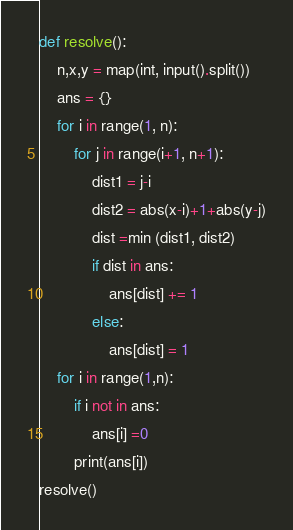Convert code to text. <code><loc_0><loc_0><loc_500><loc_500><_Python_>def resolve():
    n,x,y = map(int, input().split())
    ans = {}
    for i in range(1, n):
        for j in range(i+1, n+1):
            dist1 = j-i
            dist2 = abs(x-i)+1+abs(y-j)
            dist =min (dist1, dist2)
            if dist in ans:
                ans[dist] += 1
            else:
                ans[dist] = 1
    for i in range(1,n):
        if i not in ans:
            ans[i] =0
        print(ans[i])
resolve()</code> 